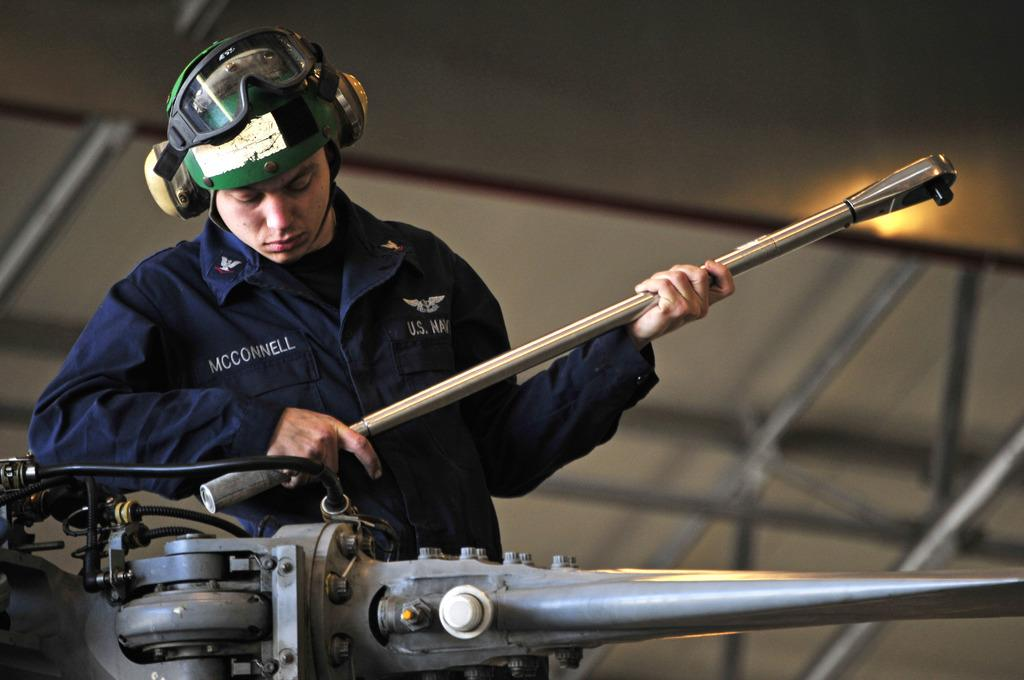Who or what is present in the image? There is a person in the image. What is the person wearing on their head? The person is wearing a helmet. What is the person holding in their hand? The person is holding an object in their hand. What can be seen in front of the person? There is a machine in front of the person. What type of leather is being rubbed on the development in the image? There is no leather or development present in the image. 